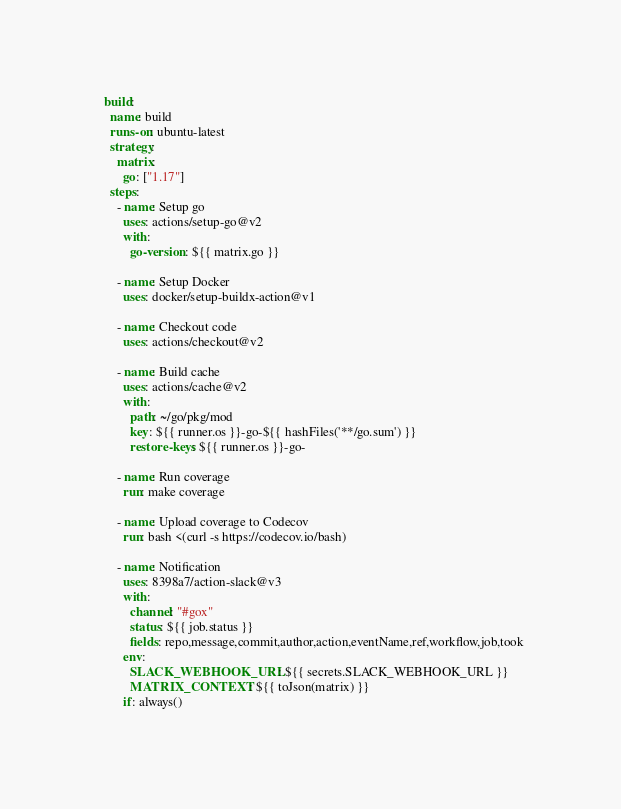Convert code to text. <code><loc_0><loc_0><loc_500><loc_500><_YAML_>  build:
    name: build
    runs-on: ubuntu-latest
    strategy:
      matrix:
        go: ["1.17"]
    steps:
      - name: Setup go
        uses: actions/setup-go@v2
        with:
          go-version: ${{ matrix.go }}

      - name: Setup Docker
        uses: docker/setup-buildx-action@v1

      - name: Checkout code
        uses: actions/checkout@v2

      - name: Build cache
        uses: actions/cache@v2
        with:
          path: ~/go/pkg/mod
          key: ${{ runner.os }}-go-${{ hashFiles('**/go.sum') }}
          restore-keys: ${{ runner.os }}-go-

      - name: Run coverage
        run: make coverage

      - name: Upload coverage to Codecov
        run: bash <(curl -s https://codecov.io/bash)

      - name: Notification
        uses: 8398a7/action-slack@v3
        with:
          channel: "#gox"
          status: ${{ job.status }}
          fields: repo,message,commit,author,action,eventName,ref,workflow,job,took
        env:
          SLACK_WEBHOOK_URL: ${{ secrets.SLACK_WEBHOOK_URL }}
          MATRIX_CONTEXT: ${{ toJson(matrix) }}
        if: always()
</code> 